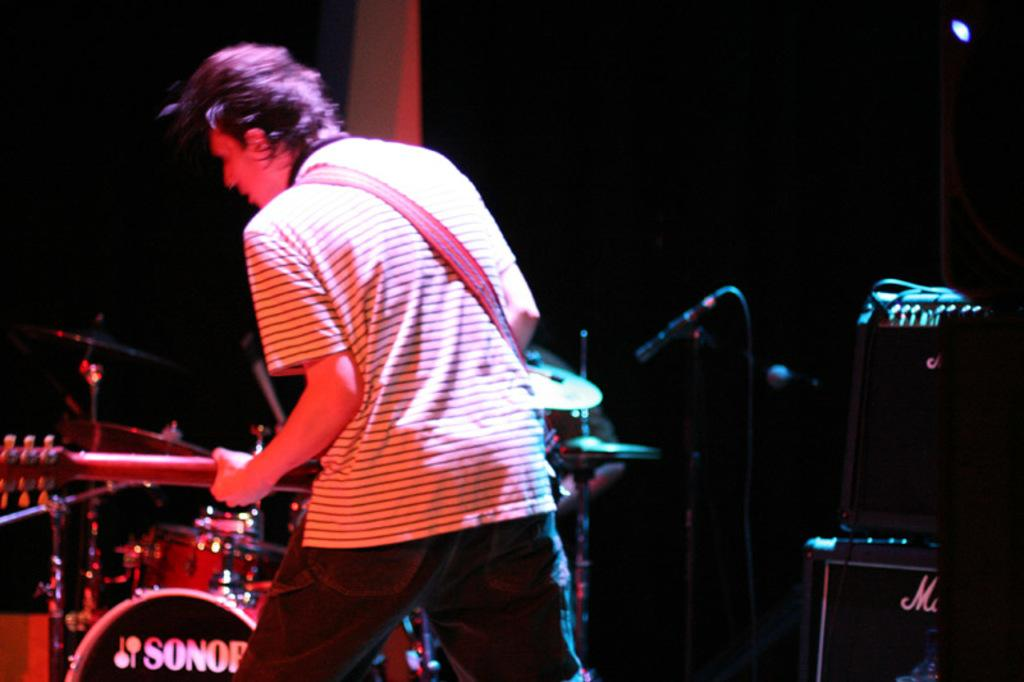What is the main subject of the image? The main subject of the image is a man. What is the man wearing in the image? The man is wearing a t-shirt in the image. What activity is the man engaged in? The man is playing a guitar in the image. What other musical elements can be seen in the image? There are musical instruments, a microphone with a holder, and speakers in the image. What type of soap is being used to clean the guitar in the image? There is no soap or cleaning activity depicted in the image; the man is simply playing the guitar. 